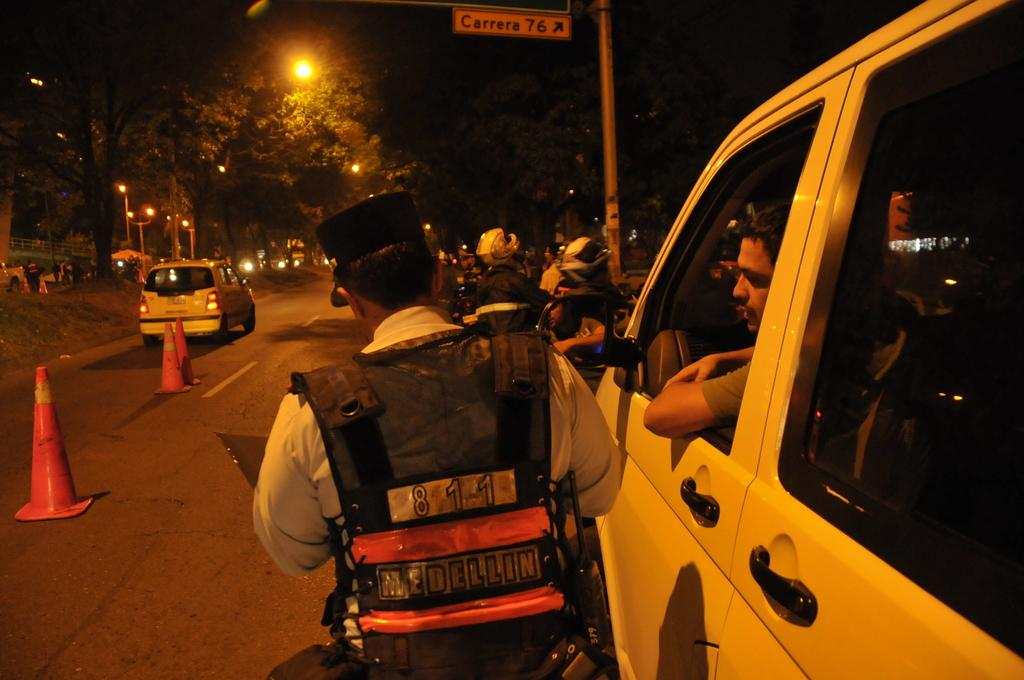<image>
Give a short and clear explanation of the subsequent image. A man wearing an 8 1 1 vest is speaking to another man in a vehicle near Carrera 76. 